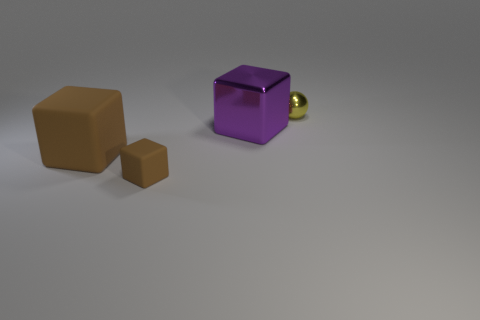Add 3 big matte objects. How many objects exist? 7 Subtract all balls. How many objects are left? 3 Add 1 small rubber blocks. How many small rubber blocks are left? 2 Add 3 objects. How many objects exist? 7 Subtract 0 yellow blocks. How many objects are left? 4 Subtract all big green blocks. Subtract all metal blocks. How many objects are left? 3 